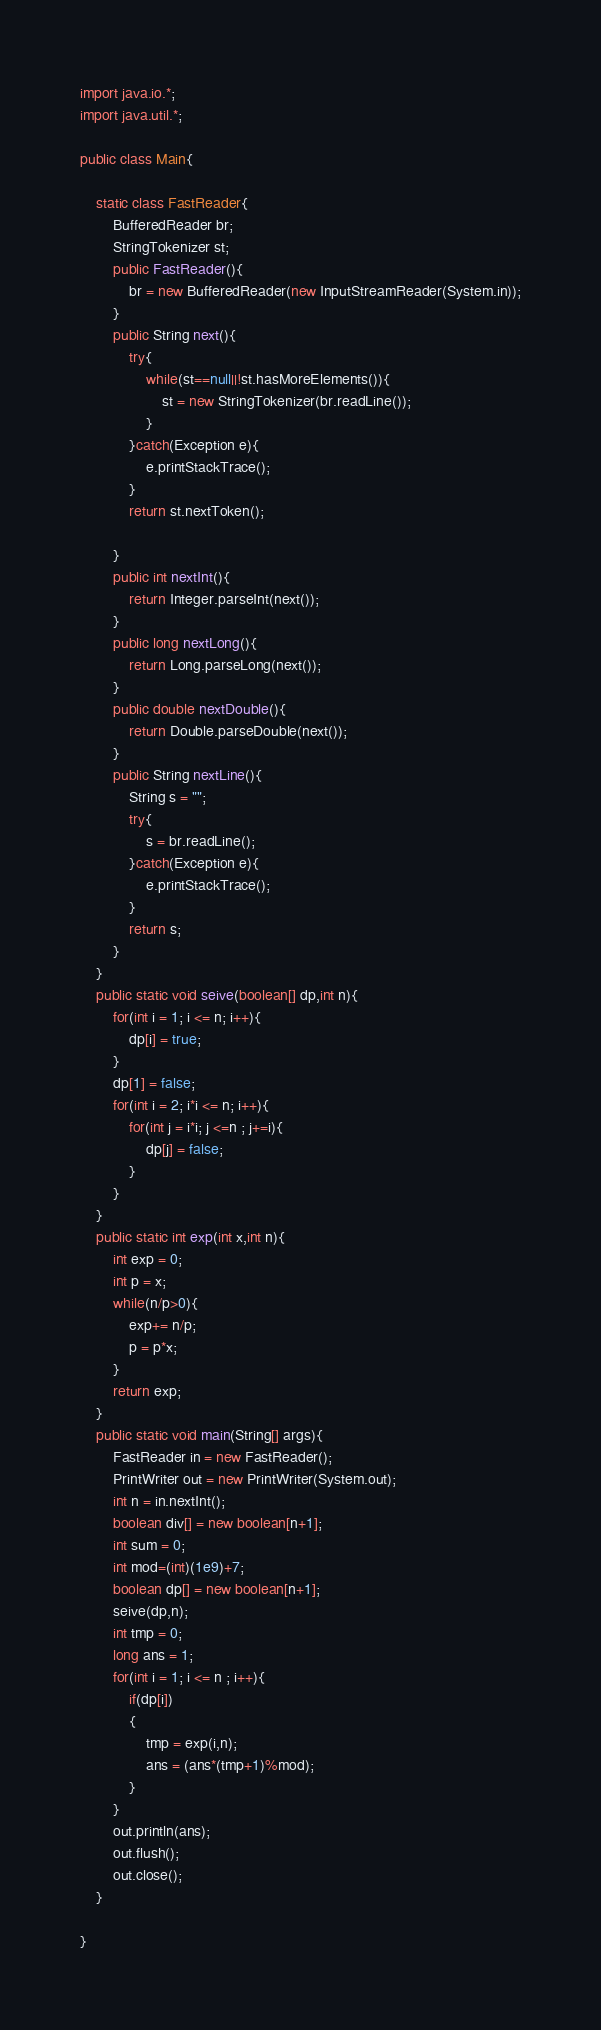Convert code to text. <code><loc_0><loc_0><loc_500><loc_500><_Java_>import java.io.*;
import java.util.*;

public class Main{

	static class FastReader{
		BufferedReader br;
		StringTokenizer st;
		public FastReader(){
			br = new BufferedReader(new InputStreamReader(System.in));
		}
		public String next(){
			try{
				while(st==null||!st.hasMoreElements()){
					st = new StringTokenizer(br.readLine());
				}
			}catch(Exception e){
				e.printStackTrace();
			}
			return st.nextToken();
	
		}
		public int nextInt(){
			return Integer.parseInt(next());
		}
		public long nextLong(){
			return Long.parseLong(next());
		}
		public double nextDouble(){
			return Double.parseDouble(next());
		}
		public String nextLine(){
			String s = "";
			try{
				s = br.readLine();
			}catch(Exception e){
				e.printStackTrace();
			}	
			return s;		
		}
	} 
	public static void seive(boolean[] dp,int n){
		for(int i = 1; i <= n; i++){
			dp[i] = true;
		}
		dp[1] = false;
		for(int i = 2; i*i <= n; i++){
			for(int j = i*i; j <=n ; j+=i){
				dp[j] = false;
			}
		}
	}
	public static int exp(int x,int n){
		int exp = 0;
		int p = x;
		while(n/p>0){
			exp+= n/p;
			p = p*x;
		}
		return exp;
	}
	public static void main(String[] args){
		FastReader in = new FastReader();
		PrintWriter out = new PrintWriter(System.out);
		int n = in.nextInt();
		boolean div[] = new boolean[n+1];
		int sum = 0;
		int mod=(int)(1e9)+7;
		boolean dp[] = new boolean[n+1];
		seive(dp,n);
		int tmp = 0;
		long ans = 1;
		for(int i = 1; i <= n ; i++){
			if(dp[i])
			{	
				tmp = exp(i,n);
				ans = (ans*(tmp+1)%mod);
			}
		}
		out.println(ans);
		out.flush();
		out.close();  
	}

}



</code> 